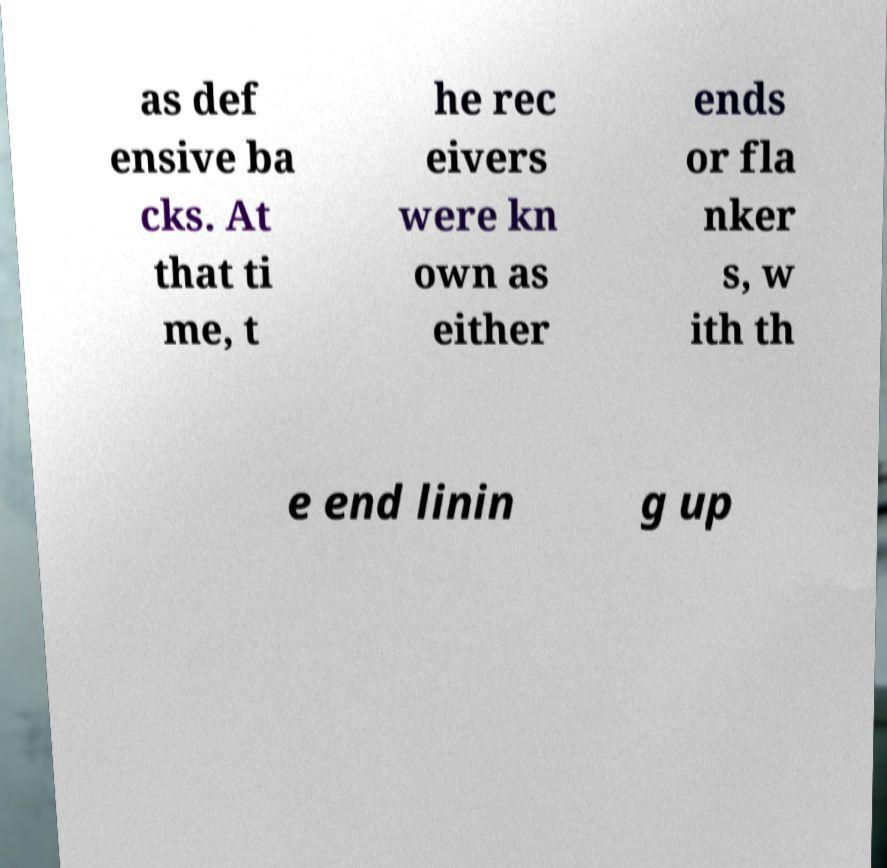Please identify and transcribe the text found in this image. as def ensive ba cks. At that ti me, t he rec eivers were kn own as either ends or fla nker s, w ith th e end linin g up 